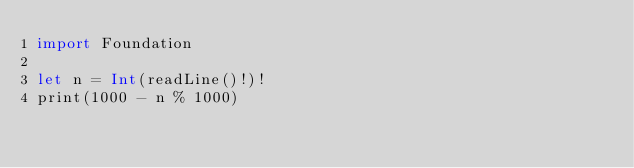<code> <loc_0><loc_0><loc_500><loc_500><_Swift_>import Foundation

let n = Int(readLine()!)!
print(1000 - n % 1000)
</code> 